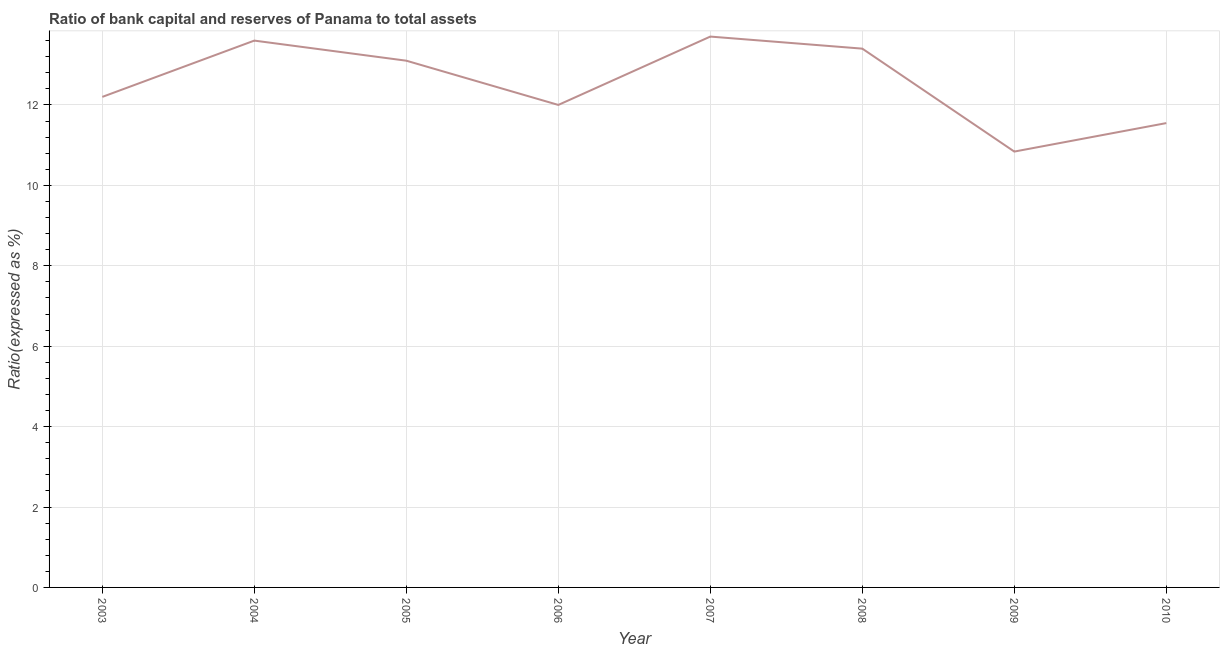Across all years, what is the maximum bank capital to assets ratio?
Your response must be concise. 13.7. Across all years, what is the minimum bank capital to assets ratio?
Give a very brief answer. 10.84. In which year was the bank capital to assets ratio minimum?
Your answer should be compact. 2009. What is the sum of the bank capital to assets ratio?
Your response must be concise. 100.39. What is the difference between the bank capital to assets ratio in 2008 and 2009?
Keep it short and to the point. 2.56. What is the average bank capital to assets ratio per year?
Your answer should be very brief. 12.55. What is the median bank capital to assets ratio?
Your answer should be very brief. 12.65. Do a majority of the years between 2004 and 2008 (inclusive) have bank capital to assets ratio greater than 7.6 %?
Make the answer very short. Yes. What is the ratio of the bank capital to assets ratio in 2004 to that in 2007?
Ensure brevity in your answer.  0.99. Is the bank capital to assets ratio in 2003 less than that in 2006?
Your response must be concise. No. What is the difference between the highest and the second highest bank capital to assets ratio?
Make the answer very short. 0.1. What is the difference between the highest and the lowest bank capital to assets ratio?
Your answer should be compact. 2.86. How many lines are there?
Provide a succinct answer. 1. How many years are there in the graph?
Offer a terse response. 8. What is the title of the graph?
Your response must be concise. Ratio of bank capital and reserves of Panama to total assets. What is the label or title of the X-axis?
Your answer should be very brief. Year. What is the label or title of the Y-axis?
Give a very brief answer. Ratio(expressed as %). What is the Ratio(expressed as %) in 2004?
Make the answer very short. 13.6. What is the Ratio(expressed as %) of 2005?
Your answer should be compact. 13.1. What is the Ratio(expressed as %) of 2006?
Provide a succinct answer. 12. What is the Ratio(expressed as %) of 2008?
Offer a terse response. 13.4. What is the Ratio(expressed as %) of 2009?
Make the answer very short. 10.84. What is the Ratio(expressed as %) in 2010?
Keep it short and to the point. 11.55. What is the difference between the Ratio(expressed as %) in 2003 and 2004?
Give a very brief answer. -1.4. What is the difference between the Ratio(expressed as %) in 2003 and 2006?
Your answer should be very brief. 0.2. What is the difference between the Ratio(expressed as %) in 2003 and 2007?
Your response must be concise. -1.5. What is the difference between the Ratio(expressed as %) in 2003 and 2008?
Offer a very short reply. -1.2. What is the difference between the Ratio(expressed as %) in 2003 and 2009?
Keep it short and to the point. 1.36. What is the difference between the Ratio(expressed as %) in 2003 and 2010?
Keep it short and to the point. 0.65. What is the difference between the Ratio(expressed as %) in 2004 and 2008?
Make the answer very short. 0.2. What is the difference between the Ratio(expressed as %) in 2004 and 2009?
Provide a succinct answer. 2.76. What is the difference between the Ratio(expressed as %) in 2004 and 2010?
Your answer should be compact. 2.05. What is the difference between the Ratio(expressed as %) in 2005 and 2008?
Offer a terse response. -0.3. What is the difference between the Ratio(expressed as %) in 2005 and 2009?
Provide a succinct answer. 2.26. What is the difference between the Ratio(expressed as %) in 2005 and 2010?
Your answer should be compact. 1.55. What is the difference between the Ratio(expressed as %) in 2006 and 2007?
Provide a short and direct response. -1.7. What is the difference between the Ratio(expressed as %) in 2006 and 2009?
Provide a short and direct response. 1.16. What is the difference between the Ratio(expressed as %) in 2006 and 2010?
Offer a very short reply. 0.45. What is the difference between the Ratio(expressed as %) in 2007 and 2008?
Your response must be concise. 0.3. What is the difference between the Ratio(expressed as %) in 2007 and 2009?
Your answer should be very brief. 2.86. What is the difference between the Ratio(expressed as %) in 2007 and 2010?
Offer a terse response. 2.15. What is the difference between the Ratio(expressed as %) in 2008 and 2009?
Your answer should be very brief. 2.56. What is the difference between the Ratio(expressed as %) in 2008 and 2010?
Provide a short and direct response. 1.85. What is the difference between the Ratio(expressed as %) in 2009 and 2010?
Provide a short and direct response. -0.71. What is the ratio of the Ratio(expressed as %) in 2003 to that in 2004?
Provide a succinct answer. 0.9. What is the ratio of the Ratio(expressed as %) in 2003 to that in 2005?
Ensure brevity in your answer.  0.93. What is the ratio of the Ratio(expressed as %) in 2003 to that in 2006?
Keep it short and to the point. 1.02. What is the ratio of the Ratio(expressed as %) in 2003 to that in 2007?
Make the answer very short. 0.89. What is the ratio of the Ratio(expressed as %) in 2003 to that in 2008?
Provide a short and direct response. 0.91. What is the ratio of the Ratio(expressed as %) in 2003 to that in 2009?
Provide a succinct answer. 1.12. What is the ratio of the Ratio(expressed as %) in 2003 to that in 2010?
Offer a terse response. 1.06. What is the ratio of the Ratio(expressed as %) in 2004 to that in 2005?
Give a very brief answer. 1.04. What is the ratio of the Ratio(expressed as %) in 2004 to that in 2006?
Your answer should be very brief. 1.13. What is the ratio of the Ratio(expressed as %) in 2004 to that in 2009?
Offer a terse response. 1.25. What is the ratio of the Ratio(expressed as %) in 2004 to that in 2010?
Provide a succinct answer. 1.18. What is the ratio of the Ratio(expressed as %) in 2005 to that in 2006?
Your response must be concise. 1.09. What is the ratio of the Ratio(expressed as %) in 2005 to that in 2007?
Keep it short and to the point. 0.96. What is the ratio of the Ratio(expressed as %) in 2005 to that in 2009?
Provide a succinct answer. 1.21. What is the ratio of the Ratio(expressed as %) in 2005 to that in 2010?
Make the answer very short. 1.13. What is the ratio of the Ratio(expressed as %) in 2006 to that in 2007?
Offer a terse response. 0.88. What is the ratio of the Ratio(expressed as %) in 2006 to that in 2008?
Make the answer very short. 0.9. What is the ratio of the Ratio(expressed as %) in 2006 to that in 2009?
Provide a succinct answer. 1.11. What is the ratio of the Ratio(expressed as %) in 2006 to that in 2010?
Provide a short and direct response. 1.04. What is the ratio of the Ratio(expressed as %) in 2007 to that in 2009?
Make the answer very short. 1.26. What is the ratio of the Ratio(expressed as %) in 2007 to that in 2010?
Your response must be concise. 1.19. What is the ratio of the Ratio(expressed as %) in 2008 to that in 2009?
Provide a short and direct response. 1.24. What is the ratio of the Ratio(expressed as %) in 2008 to that in 2010?
Give a very brief answer. 1.16. What is the ratio of the Ratio(expressed as %) in 2009 to that in 2010?
Offer a terse response. 0.94. 